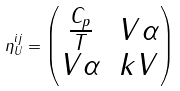<formula> <loc_0><loc_0><loc_500><loc_500>\eta ^ { i j } _ { U } = \begin{pmatrix} \frac { C _ { p } } { T } & V \alpha \\ V \alpha & k V \end{pmatrix}</formula> 